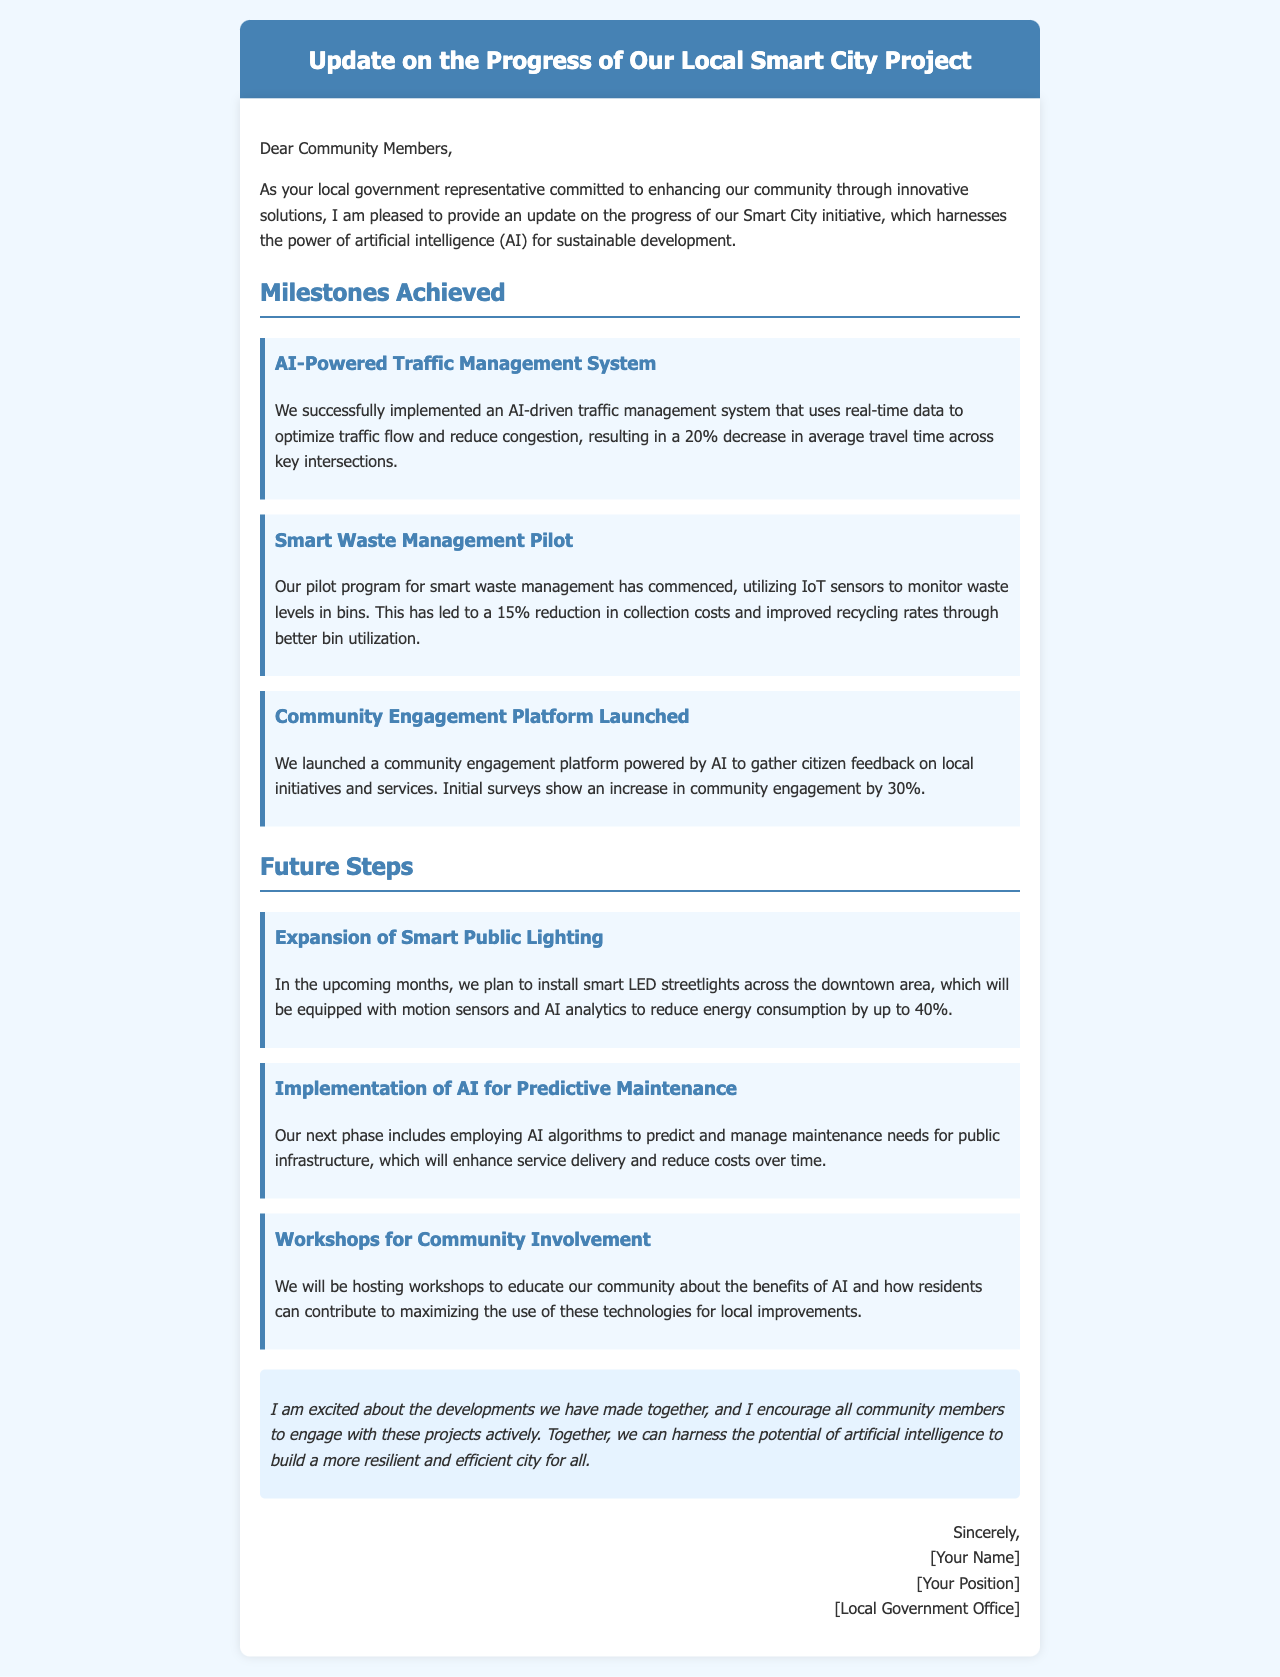What is the title of the document? The title of the document is presented in the header section, indicating the subject of the update.
Answer: Update on the Progress of Our Local Smart City Project What was the percentage decrease in average travel time due to the traffic management system? The text specifies the impact of the AI-powered traffic management system on travel time in a concrete percentage.
Answer: 20% What type of platform was launched to gather citizen feedback? The section discussing community engagement mentions the specific type of platform introduced in the project.
Answer: Community Engagement Platform What is the expected reduction in energy consumption from smart LED streetlights? The future steps detail the anticipated outcomes of installing smart LED streetlights, including a specific percentage of energy savings.
Answer: 40% What will the next phase involve in terms of public infrastructure maintenance? The description of future steps indicates a focus on predicting and managing maintenance needs, highlighting the technology to be implemented.
Answer: AI algorithms How much reduction in collection costs was achieved through the smart waste management pilot? In the milestones section, the accomplishments of the pilot program are quantified, highlighting its financial impact.
Answer: 15% What increase in community engagement was observed from initial surveys? The community engagement data section quantifies the rise in community interaction following the launch of the platform.
Answer: 30% What type of workshops will be hosted for community involvement? The future steps section specifies the nature and purpose of the planned workshops as a means for community education.
Answer: Workshops to educate about AI What is the primary goal of the Smart City initiative mentioned in the document? The opening paragraph succinctly describes the overarching aim of the local government’s project, focusing on community enhancement.
Answer: Sustainable development 